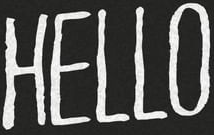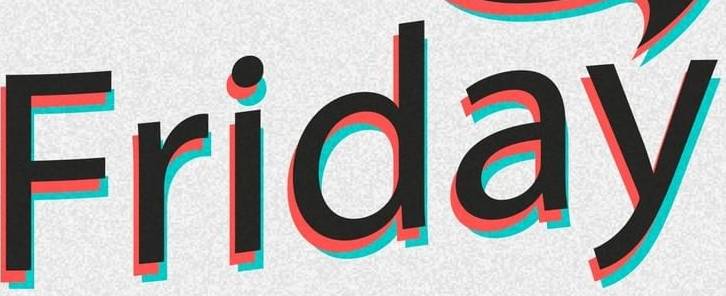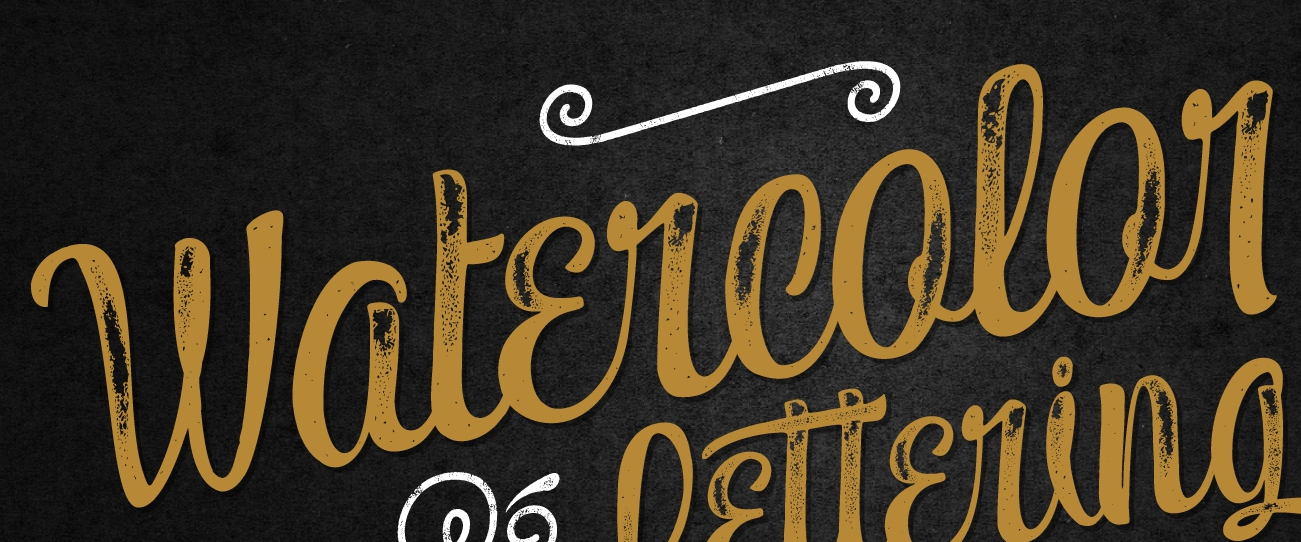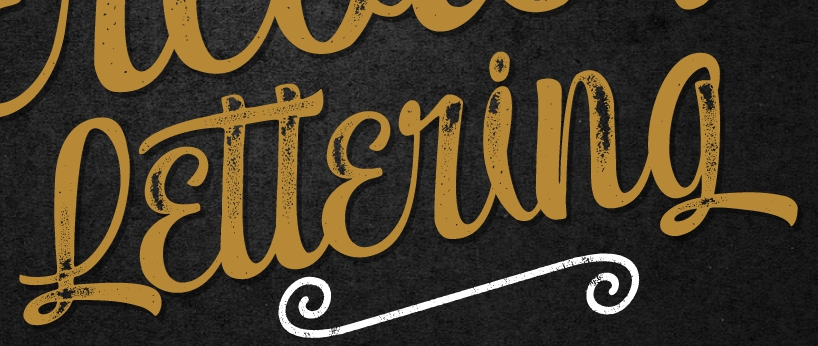Transcribe the words shown in these images in order, separated by a semicolon. HELLO; Friday; Watɛrcolor; Lɛttɛring 